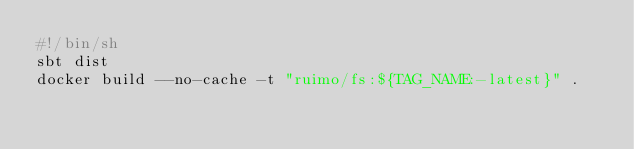<code> <loc_0><loc_0><loc_500><loc_500><_Bash_>#!/bin/sh
sbt dist
docker build --no-cache -t "ruimo/fs:${TAG_NAME:-latest}" .
</code> 